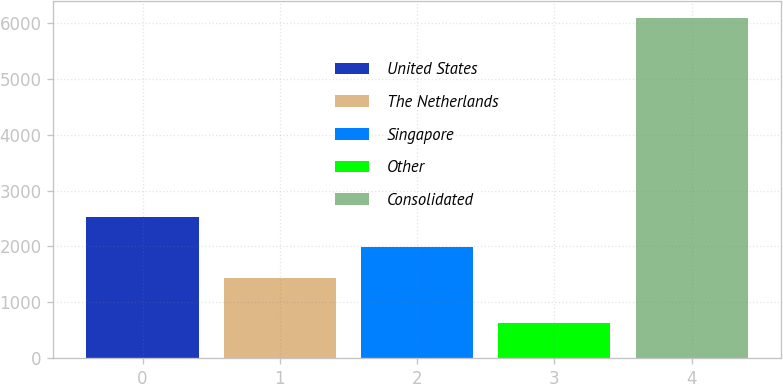<chart> <loc_0><loc_0><loc_500><loc_500><bar_chart><fcel>United States<fcel>The Netherlands<fcel>Singapore<fcel>Other<fcel>Consolidated<nl><fcel>2530.6<fcel>1438<fcel>1984.3<fcel>624<fcel>6087<nl></chart> 